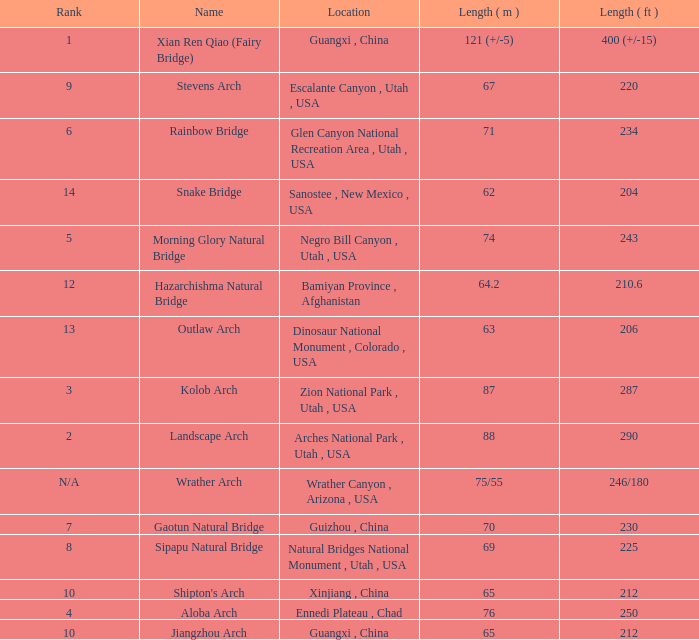Where is the longest arch with a length in meters of 63? Dinosaur National Monument , Colorado , USA. 